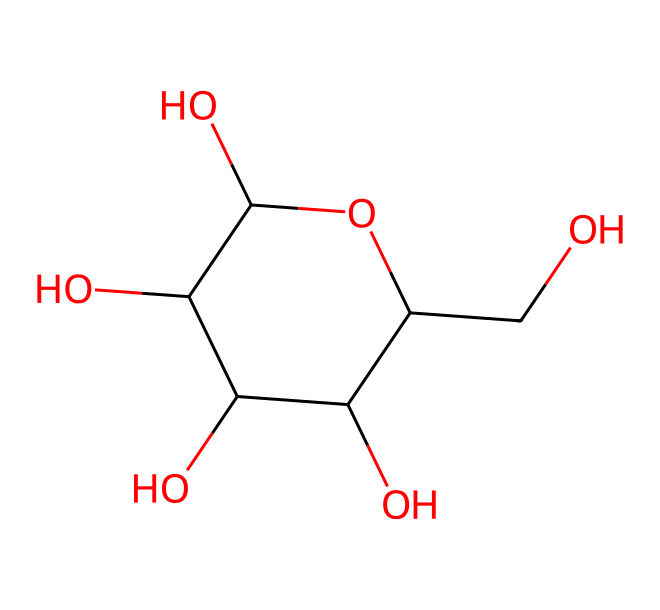What is the molecular formula of glucose based on its SMILES? The SMILES representation indicates the structure's components. By counting the carbon (C), hydrogen (H), and oxygen (O) atoms, there are six carbon atoms, twelve hydrogen atoms, and six oxygen atoms, which gives the formula C6H12O6.
Answer: C6H12O6 How many hydroxyl (–OH) groups are present in this molecule? The structure of glucose includes multiple hydroxyl groups, characterized by the –OH notation. In examining the SMILES, we find that there are five –OH groups attached to the carbon backbone of glucose.
Answer: 5 What type of carbohydrate is glucose categorized as? Glucose, which has a simple structure with a basic monomeric unit, is categorized as a monosaccharide. This is the simplest form of sugar and serves as a building block for more complex carbohydrates.
Answer: monosaccharide Which functional groups are prominently featured in glucose? The glucose molecule prominently features hydroxyl (–OH) groups and an aldehyde (–CHO) group at the first carbon atom. The presence of these groups classifies glucose as an aldehyde sugar, giving it unique chemical properties.
Answer: hydroxyl and aldehyde groups How many carbon atoms are in the glucose structure? By analyzing the SMILES representation, we can see that glucose contains a total of six carbon atoms arranged in a ring structure and a side chain. This can be confirmed by counting them directly in the structure.
Answer: 6 What is the significance of glucose in biological systems? Glucose is often referred to as blood sugar and is crucial in biological systems as an energy source. It plays a central role in cellular respiration, metabolism, and is a primary energy carrier in living organisms.
Answer: energy source Is glucose a reducing sugar? Yes, glucose is a reducing sugar because it has a free aldehyde group that can donate electrons, thus reducing other molecules during chemical reactions. This property is vital in various biochemical pathways.
Answer: yes 